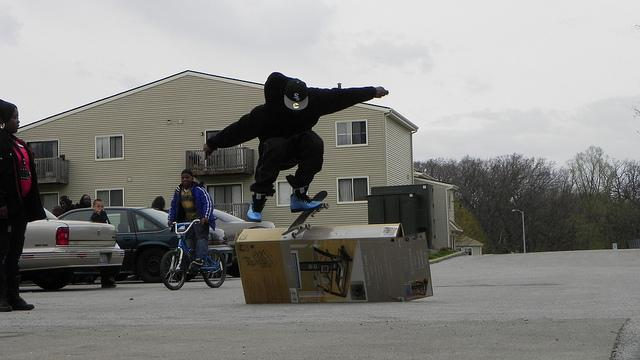What is the average size of skateboard? Please explain your reasoning. 8inches. The average skateboard is over a foot. 